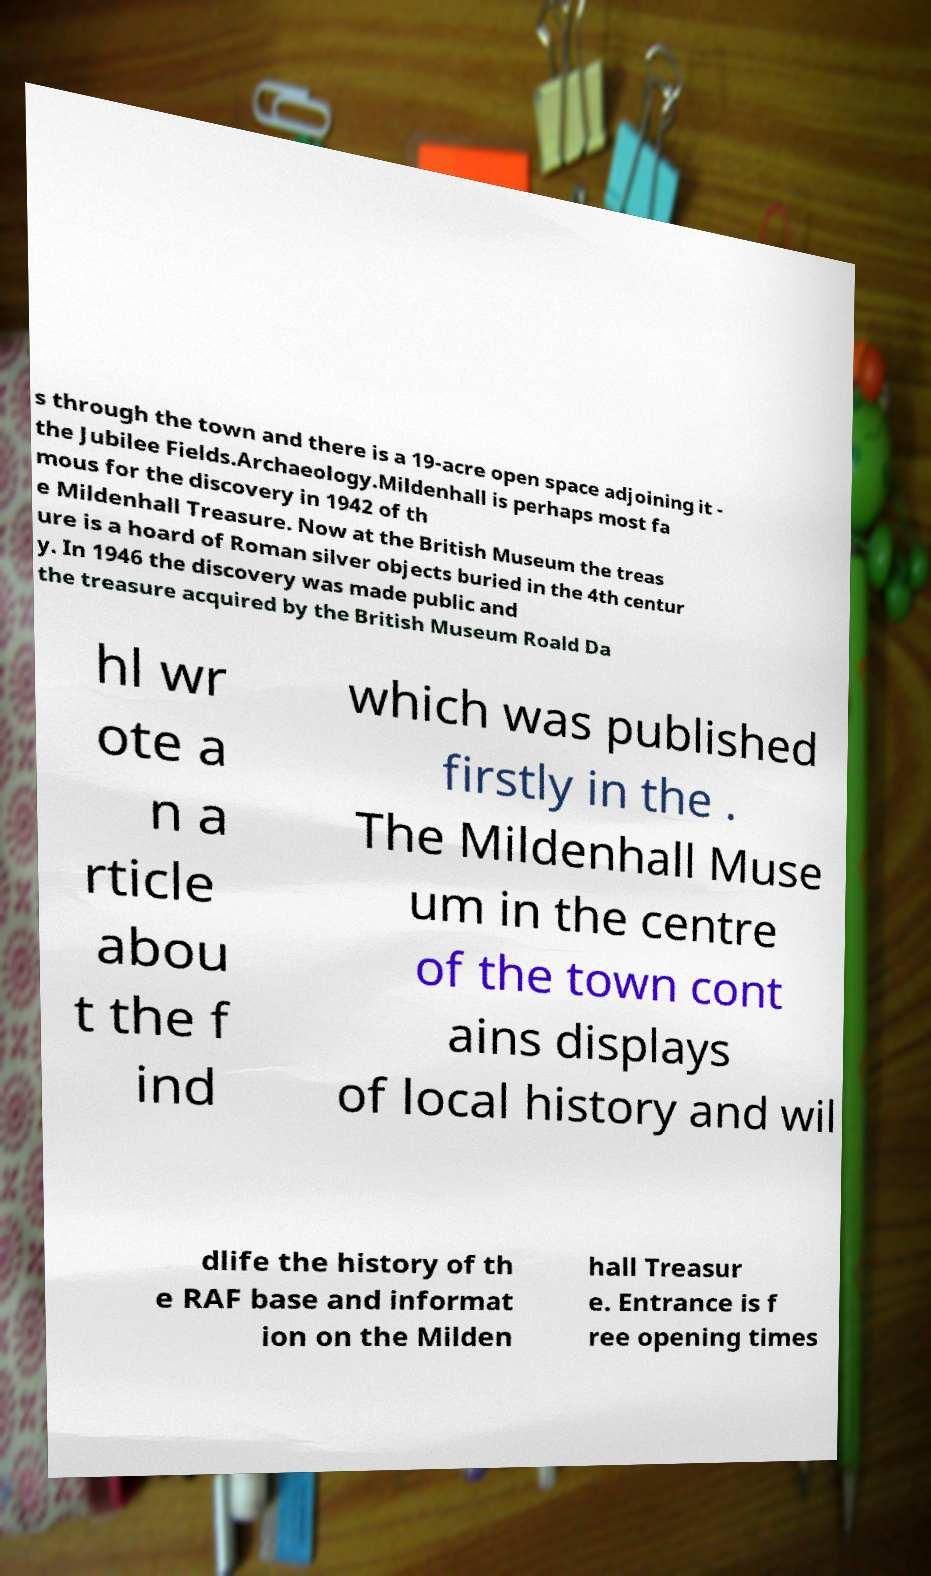Could you extract and type out the text from this image? s through the town and there is a 19-acre open space adjoining it - the Jubilee Fields.Archaeology.Mildenhall is perhaps most fa mous for the discovery in 1942 of th e Mildenhall Treasure. Now at the British Museum the treas ure is a hoard of Roman silver objects buried in the 4th centur y. In 1946 the discovery was made public and the treasure acquired by the British Museum Roald Da hl wr ote a n a rticle abou t the f ind which was published firstly in the . The Mildenhall Muse um in the centre of the town cont ains displays of local history and wil dlife the history of th e RAF base and informat ion on the Milden hall Treasur e. Entrance is f ree opening times 